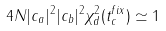Convert formula to latex. <formula><loc_0><loc_0><loc_500><loc_500>4 N | c _ { a } | ^ { 2 } | c _ { b } | ^ { 2 } \chi _ { d } ^ { 2 } ( t _ { c } ^ { f i x } ) \simeq 1</formula> 